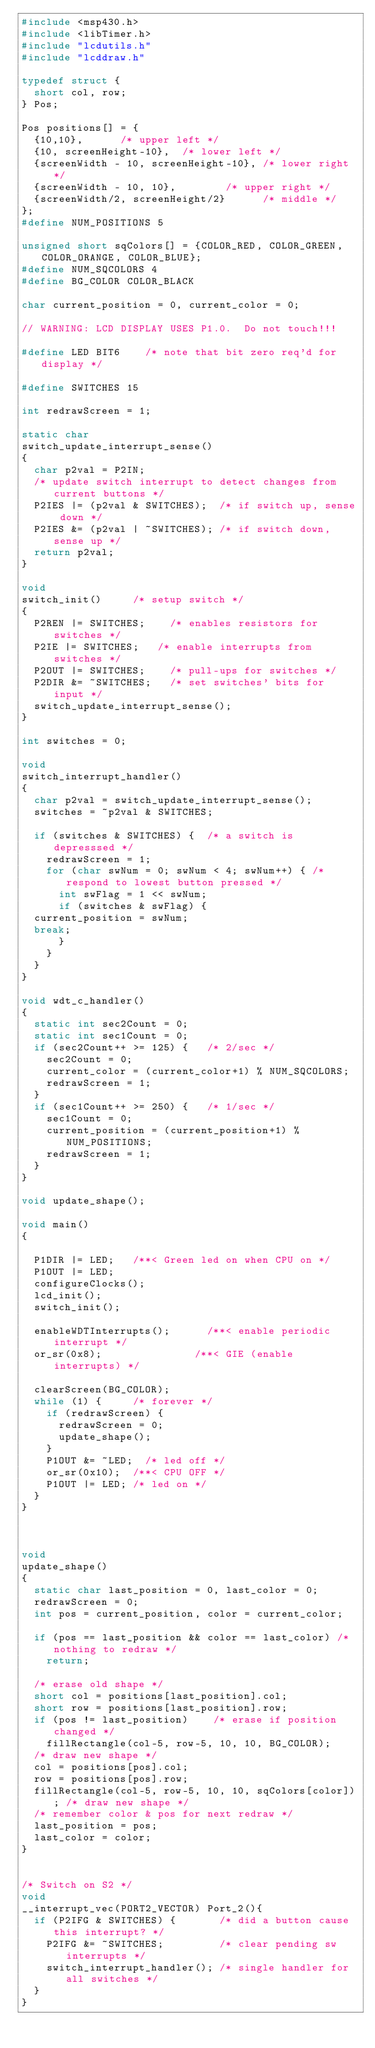<code> <loc_0><loc_0><loc_500><loc_500><_C_>#include <msp430.h>
#include <libTimer.h>
#include "lcdutils.h"
#include "lcddraw.h"

typedef struct {
  short col, row;
} Pos;

Pos positions[] = {
  {10,10},			/* upper left */
  {10, screenHeight-10}, 	/* lower left */
  {screenWidth - 10, screenHeight-10}, /* lower right */
  {screenWidth - 10, 10},	       /* upper right */
  {screenWidth/2, screenHeight/2}      /* middle */
};
#define NUM_POSITIONS 5

unsigned short sqColors[] = {COLOR_RED, COLOR_GREEN, COLOR_ORANGE, COLOR_BLUE};
#define NUM_SQCOLORS 4
#define BG_COLOR COLOR_BLACK

char current_position = 0, current_color = 0;
  
// WARNING: LCD DISPLAY USES P1.0.  Do not touch!!! 

#define LED BIT6		/* note that bit zero req'd for display */

#define SWITCHES 15

int redrawScreen = 1;

static char 
switch_update_interrupt_sense()
{
  char p2val = P2IN;
  /* update switch interrupt to detect changes from current buttons */
  P2IES |= (p2val & SWITCHES);	/* if switch up, sense down */
  P2IES &= (p2val | ~SWITCHES);	/* if switch down, sense up */
  return p2val;
}

void 
switch_init()			/* setup switch */
{  
  P2REN |= SWITCHES;		/* enables resistors for switches */
  P2IE |= SWITCHES;		/* enable interrupts from switches */
  P2OUT |= SWITCHES;		/* pull-ups for switches */
  P2DIR &= ~SWITCHES;		/* set switches' bits for input */
  switch_update_interrupt_sense();
}

int switches = 0;

void
switch_interrupt_handler()
{
  char p2val = switch_update_interrupt_sense();
  switches = ~p2val & SWITCHES;

  if (switches & SWITCHES) { 	/* a switch is depresssed */
    redrawScreen = 1;
    for (char swNum = 0; swNum < 4; swNum++) { /* respond to lowest button pressed */
      int swFlag = 1 << swNum;
      if (switches & swFlag) {
	current_position = swNum;
	break;
      }
    }
  }
}

void wdt_c_handler()
{
  static int sec2Count = 0;
  static int sec1Count = 0;
  if (sec2Count++ >= 125) {		/* 2/sec */
    sec2Count = 0;
    current_color = (current_color+1) % NUM_SQCOLORS;
    redrawScreen = 1;
  }
  if (sec1Count++ >= 250) {		/* 1/sec */
    sec1Count = 0;
    current_position = (current_position+1) % NUM_POSITIONS;
    redrawScreen = 1;
  }
}
  
void update_shape();

void main()
{
  
  P1DIR |= LED;		/**< Green led on when CPU on */
  P1OUT |= LED;
  configureClocks();
  lcd_init();
  switch_init();
  
  enableWDTInterrupts();      /**< enable periodic interrupt */
  or_sr(0x8);	              /**< GIE (enable interrupts) */
  
  clearScreen(BG_COLOR);
  while (1) {			/* forever */
    if (redrawScreen) {
      redrawScreen = 0;
      update_shape();
    }
    P1OUT &= ~LED;	/* led off */
    or_sr(0x10);	/**< CPU OFF */
    P1OUT |= LED;	/* led on */
  }
}

    
    
void
update_shape()
{
  static char last_position = 0, last_color = 0;
  redrawScreen = 0;
  int pos = current_position, color = current_color;

  if (pos == last_position && color == last_color) /* nothing to redraw */
    return;

  /* erase old shape */
  short col = positions[last_position].col;
  short row = positions[last_position].row;
  if (pos != last_position)    /* erase if position changed */
    fillRectangle(col-5, row-5, 10, 10, BG_COLOR); 
  /* draw new shape */
  col = positions[pos].col;
  row = positions[pos].row;
  fillRectangle(col-5, row-5, 10, 10, sqColors[color]); /* draw new shape */
  /* remember color & pos for next redraw */
  last_position = pos;
  last_color = color;
}


/* Switch on S2 */
void
__interrupt_vec(PORT2_VECTOR) Port_2(){
  if (P2IFG & SWITCHES) {	      /* did a button cause this interrupt? */
    P2IFG &= ~SWITCHES;		      /* clear pending sw interrupts */
    switch_interrupt_handler();	/* single handler for all switches */
  }
}
</code> 